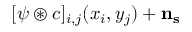<formula> <loc_0><loc_0><loc_500><loc_500>[ \psi \circledast c ] _ { i , j } ( x _ { i } , y _ { j } ) + n _ { s }</formula> 